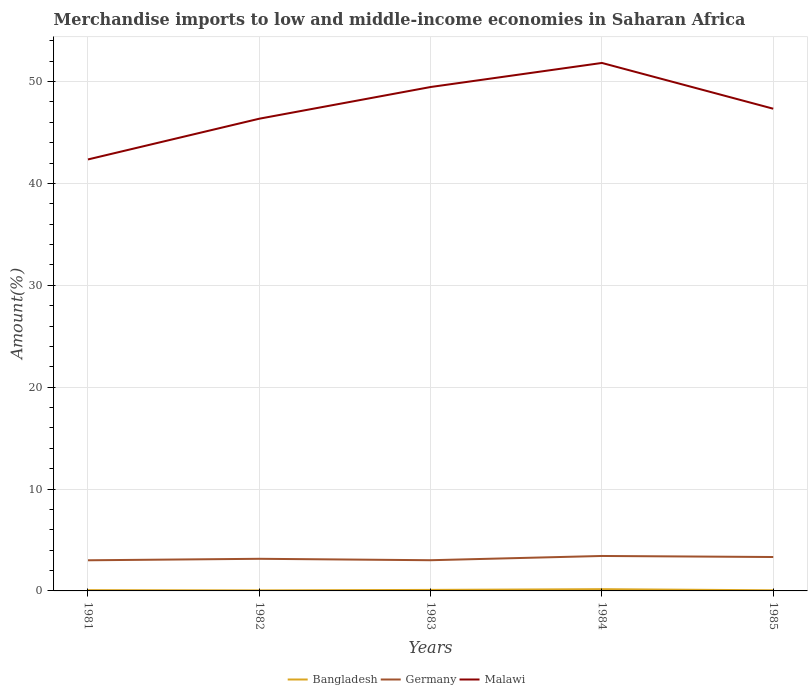Across all years, what is the maximum percentage of amount earned from merchandise imports in Malawi?
Your answer should be compact. 42.35. What is the total percentage of amount earned from merchandise imports in Germany in the graph?
Offer a very short reply. -0.15. What is the difference between the highest and the second highest percentage of amount earned from merchandise imports in Malawi?
Offer a very short reply. 9.47. How many lines are there?
Keep it short and to the point. 3. How many years are there in the graph?
Provide a succinct answer. 5. What is the difference between two consecutive major ticks on the Y-axis?
Offer a terse response. 10. What is the title of the graph?
Offer a terse response. Merchandise imports to low and middle-income economies in Saharan Africa. Does "Bolivia" appear as one of the legend labels in the graph?
Provide a short and direct response. No. What is the label or title of the Y-axis?
Make the answer very short. Amount(%). What is the Amount(%) of Bangladesh in 1981?
Your response must be concise. 0.07. What is the Amount(%) in Germany in 1981?
Keep it short and to the point. 3.01. What is the Amount(%) in Malawi in 1981?
Offer a terse response. 42.35. What is the Amount(%) of Bangladesh in 1982?
Provide a short and direct response. 0.05. What is the Amount(%) of Germany in 1982?
Give a very brief answer. 3.15. What is the Amount(%) of Malawi in 1982?
Your answer should be very brief. 46.35. What is the Amount(%) in Bangladesh in 1983?
Keep it short and to the point. 0.1. What is the Amount(%) in Germany in 1983?
Give a very brief answer. 3.01. What is the Amount(%) of Malawi in 1983?
Provide a succinct answer. 49.46. What is the Amount(%) in Bangladesh in 1984?
Your answer should be very brief. 0.17. What is the Amount(%) in Germany in 1984?
Offer a very short reply. 3.43. What is the Amount(%) in Malawi in 1984?
Offer a very short reply. 51.82. What is the Amount(%) of Bangladesh in 1985?
Your answer should be very brief. 0.06. What is the Amount(%) of Germany in 1985?
Offer a very short reply. 3.33. What is the Amount(%) in Malawi in 1985?
Provide a short and direct response. 47.33. Across all years, what is the maximum Amount(%) in Bangladesh?
Provide a short and direct response. 0.17. Across all years, what is the maximum Amount(%) of Germany?
Ensure brevity in your answer.  3.43. Across all years, what is the maximum Amount(%) in Malawi?
Your answer should be very brief. 51.82. Across all years, what is the minimum Amount(%) of Bangladesh?
Keep it short and to the point. 0.05. Across all years, what is the minimum Amount(%) of Germany?
Your answer should be very brief. 3.01. Across all years, what is the minimum Amount(%) in Malawi?
Make the answer very short. 42.35. What is the total Amount(%) of Bangladesh in the graph?
Your response must be concise. 0.46. What is the total Amount(%) in Germany in the graph?
Keep it short and to the point. 15.93. What is the total Amount(%) in Malawi in the graph?
Provide a short and direct response. 237.3. What is the difference between the Amount(%) of Bangladesh in 1981 and that in 1982?
Offer a very short reply. 0.02. What is the difference between the Amount(%) of Germany in 1981 and that in 1982?
Your response must be concise. -0.15. What is the difference between the Amount(%) in Malawi in 1981 and that in 1982?
Provide a succinct answer. -4. What is the difference between the Amount(%) of Bangladesh in 1981 and that in 1983?
Ensure brevity in your answer.  -0.02. What is the difference between the Amount(%) in Germany in 1981 and that in 1983?
Your answer should be compact. -0.01. What is the difference between the Amount(%) in Malawi in 1981 and that in 1983?
Make the answer very short. -7.11. What is the difference between the Amount(%) in Bangladesh in 1981 and that in 1984?
Give a very brief answer. -0.1. What is the difference between the Amount(%) of Germany in 1981 and that in 1984?
Your answer should be very brief. -0.42. What is the difference between the Amount(%) in Malawi in 1981 and that in 1984?
Give a very brief answer. -9.47. What is the difference between the Amount(%) of Bangladesh in 1981 and that in 1985?
Your answer should be very brief. 0.01. What is the difference between the Amount(%) of Germany in 1981 and that in 1985?
Give a very brief answer. -0.32. What is the difference between the Amount(%) in Malawi in 1981 and that in 1985?
Keep it short and to the point. -4.98. What is the difference between the Amount(%) in Bangladesh in 1982 and that in 1983?
Keep it short and to the point. -0.05. What is the difference between the Amount(%) in Germany in 1982 and that in 1983?
Offer a terse response. 0.14. What is the difference between the Amount(%) in Malawi in 1982 and that in 1983?
Offer a terse response. -3.11. What is the difference between the Amount(%) in Bangladesh in 1982 and that in 1984?
Offer a very short reply. -0.12. What is the difference between the Amount(%) in Germany in 1982 and that in 1984?
Offer a terse response. -0.28. What is the difference between the Amount(%) in Malawi in 1982 and that in 1984?
Give a very brief answer. -5.47. What is the difference between the Amount(%) of Bangladesh in 1982 and that in 1985?
Your response must be concise. -0.01. What is the difference between the Amount(%) in Germany in 1982 and that in 1985?
Your response must be concise. -0.17. What is the difference between the Amount(%) in Malawi in 1982 and that in 1985?
Offer a very short reply. -0.98. What is the difference between the Amount(%) in Bangladesh in 1983 and that in 1984?
Your answer should be compact. -0.07. What is the difference between the Amount(%) in Germany in 1983 and that in 1984?
Give a very brief answer. -0.42. What is the difference between the Amount(%) in Malawi in 1983 and that in 1984?
Make the answer very short. -2.36. What is the difference between the Amount(%) in Bangladesh in 1983 and that in 1985?
Your answer should be very brief. 0.04. What is the difference between the Amount(%) of Germany in 1983 and that in 1985?
Provide a short and direct response. -0.31. What is the difference between the Amount(%) of Malawi in 1983 and that in 1985?
Provide a short and direct response. 2.13. What is the difference between the Amount(%) in Bangladesh in 1984 and that in 1985?
Provide a short and direct response. 0.11. What is the difference between the Amount(%) in Germany in 1984 and that in 1985?
Your response must be concise. 0.1. What is the difference between the Amount(%) of Malawi in 1984 and that in 1985?
Your response must be concise. 4.49. What is the difference between the Amount(%) of Bangladesh in 1981 and the Amount(%) of Germany in 1982?
Ensure brevity in your answer.  -3.08. What is the difference between the Amount(%) in Bangladesh in 1981 and the Amount(%) in Malawi in 1982?
Give a very brief answer. -46.27. What is the difference between the Amount(%) in Germany in 1981 and the Amount(%) in Malawi in 1982?
Ensure brevity in your answer.  -43.34. What is the difference between the Amount(%) in Bangladesh in 1981 and the Amount(%) in Germany in 1983?
Offer a terse response. -2.94. What is the difference between the Amount(%) of Bangladesh in 1981 and the Amount(%) of Malawi in 1983?
Ensure brevity in your answer.  -49.38. What is the difference between the Amount(%) of Germany in 1981 and the Amount(%) of Malawi in 1983?
Provide a succinct answer. -46.45. What is the difference between the Amount(%) of Bangladesh in 1981 and the Amount(%) of Germany in 1984?
Offer a very short reply. -3.36. What is the difference between the Amount(%) of Bangladesh in 1981 and the Amount(%) of Malawi in 1984?
Offer a very short reply. -51.75. What is the difference between the Amount(%) in Germany in 1981 and the Amount(%) in Malawi in 1984?
Give a very brief answer. -48.81. What is the difference between the Amount(%) in Bangladesh in 1981 and the Amount(%) in Germany in 1985?
Make the answer very short. -3.25. What is the difference between the Amount(%) in Bangladesh in 1981 and the Amount(%) in Malawi in 1985?
Your answer should be very brief. -47.25. What is the difference between the Amount(%) in Germany in 1981 and the Amount(%) in Malawi in 1985?
Your answer should be compact. -44.32. What is the difference between the Amount(%) of Bangladesh in 1982 and the Amount(%) of Germany in 1983?
Ensure brevity in your answer.  -2.96. What is the difference between the Amount(%) in Bangladesh in 1982 and the Amount(%) in Malawi in 1983?
Provide a succinct answer. -49.41. What is the difference between the Amount(%) of Germany in 1982 and the Amount(%) of Malawi in 1983?
Provide a succinct answer. -46.3. What is the difference between the Amount(%) of Bangladesh in 1982 and the Amount(%) of Germany in 1984?
Offer a terse response. -3.38. What is the difference between the Amount(%) in Bangladesh in 1982 and the Amount(%) in Malawi in 1984?
Keep it short and to the point. -51.77. What is the difference between the Amount(%) in Germany in 1982 and the Amount(%) in Malawi in 1984?
Offer a terse response. -48.67. What is the difference between the Amount(%) of Bangladesh in 1982 and the Amount(%) of Germany in 1985?
Give a very brief answer. -3.28. What is the difference between the Amount(%) of Bangladesh in 1982 and the Amount(%) of Malawi in 1985?
Make the answer very short. -47.28. What is the difference between the Amount(%) of Germany in 1982 and the Amount(%) of Malawi in 1985?
Make the answer very short. -44.17. What is the difference between the Amount(%) in Bangladesh in 1983 and the Amount(%) in Germany in 1984?
Provide a succinct answer. -3.33. What is the difference between the Amount(%) of Bangladesh in 1983 and the Amount(%) of Malawi in 1984?
Your answer should be very brief. -51.72. What is the difference between the Amount(%) in Germany in 1983 and the Amount(%) in Malawi in 1984?
Your answer should be compact. -48.81. What is the difference between the Amount(%) of Bangladesh in 1983 and the Amount(%) of Germany in 1985?
Give a very brief answer. -3.23. What is the difference between the Amount(%) of Bangladesh in 1983 and the Amount(%) of Malawi in 1985?
Provide a succinct answer. -47.23. What is the difference between the Amount(%) in Germany in 1983 and the Amount(%) in Malawi in 1985?
Ensure brevity in your answer.  -44.31. What is the difference between the Amount(%) in Bangladesh in 1984 and the Amount(%) in Germany in 1985?
Provide a short and direct response. -3.16. What is the difference between the Amount(%) of Bangladesh in 1984 and the Amount(%) of Malawi in 1985?
Ensure brevity in your answer.  -47.16. What is the difference between the Amount(%) of Germany in 1984 and the Amount(%) of Malawi in 1985?
Provide a short and direct response. -43.9. What is the average Amount(%) of Bangladesh per year?
Your response must be concise. 0.09. What is the average Amount(%) of Germany per year?
Ensure brevity in your answer.  3.19. What is the average Amount(%) of Malawi per year?
Keep it short and to the point. 47.46. In the year 1981, what is the difference between the Amount(%) of Bangladesh and Amount(%) of Germany?
Offer a very short reply. -2.93. In the year 1981, what is the difference between the Amount(%) of Bangladesh and Amount(%) of Malawi?
Provide a succinct answer. -42.27. In the year 1981, what is the difference between the Amount(%) in Germany and Amount(%) in Malawi?
Give a very brief answer. -39.34. In the year 1982, what is the difference between the Amount(%) of Bangladesh and Amount(%) of Germany?
Your answer should be very brief. -3.1. In the year 1982, what is the difference between the Amount(%) in Bangladesh and Amount(%) in Malawi?
Ensure brevity in your answer.  -46.3. In the year 1982, what is the difference between the Amount(%) of Germany and Amount(%) of Malawi?
Give a very brief answer. -43.19. In the year 1983, what is the difference between the Amount(%) of Bangladesh and Amount(%) of Germany?
Make the answer very short. -2.91. In the year 1983, what is the difference between the Amount(%) in Bangladesh and Amount(%) in Malawi?
Ensure brevity in your answer.  -49.36. In the year 1983, what is the difference between the Amount(%) of Germany and Amount(%) of Malawi?
Make the answer very short. -46.44. In the year 1984, what is the difference between the Amount(%) of Bangladesh and Amount(%) of Germany?
Ensure brevity in your answer.  -3.26. In the year 1984, what is the difference between the Amount(%) in Bangladesh and Amount(%) in Malawi?
Ensure brevity in your answer.  -51.65. In the year 1984, what is the difference between the Amount(%) of Germany and Amount(%) of Malawi?
Your answer should be very brief. -48.39. In the year 1985, what is the difference between the Amount(%) of Bangladesh and Amount(%) of Germany?
Offer a very short reply. -3.27. In the year 1985, what is the difference between the Amount(%) of Bangladesh and Amount(%) of Malawi?
Your answer should be very brief. -47.27. In the year 1985, what is the difference between the Amount(%) of Germany and Amount(%) of Malawi?
Provide a short and direct response. -44. What is the ratio of the Amount(%) of Bangladesh in 1981 to that in 1982?
Offer a terse response. 1.44. What is the ratio of the Amount(%) in Germany in 1981 to that in 1982?
Provide a short and direct response. 0.95. What is the ratio of the Amount(%) in Malawi in 1981 to that in 1982?
Give a very brief answer. 0.91. What is the ratio of the Amount(%) in Bangladesh in 1981 to that in 1983?
Ensure brevity in your answer.  0.75. What is the ratio of the Amount(%) in Malawi in 1981 to that in 1983?
Offer a very short reply. 0.86. What is the ratio of the Amount(%) in Bangladesh in 1981 to that in 1984?
Your answer should be compact. 0.44. What is the ratio of the Amount(%) of Germany in 1981 to that in 1984?
Offer a very short reply. 0.88. What is the ratio of the Amount(%) of Malawi in 1981 to that in 1984?
Ensure brevity in your answer.  0.82. What is the ratio of the Amount(%) of Bangladesh in 1981 to that in 1985?
Provide a succinct answer. 1.23. What is the ratio of the Amount(%) in Germany in 1981 to that in 1985?
Provide a short and direct response. 0.9. What is the ratio of the Amount(%) in Malawi in 1981 to that in 1985?
Keep it short and to the point. 0.89. What is the ratio of the Amount(%) of Bangladesh in 1982 to that in 1983?
Your answer should be compact. 0.52. What is the ratio of the Amount(%) in Germany in 1982 to that in 1983?
Your response must be concise. 1.05. What is the ratio of the Amount(%) of Malawi in 1982 to that in 1983?
Keep it short and to the point. 0.94. What is the ratio of the Amount(%) of Bangladesh in 1982 to that in 1984?
Provide a succinct answer. 0.3. What is the ratio of the Amount(%) in Germany in 1982 to that in 1984?
Your answer should be compact. 0.92. What is the ratio of the Amount(%) of Malawi in 1982 to that in 1984?
Give a very brief answer. 0.89. What is the ratio of the Amount(%) in Bangladesh in 1982 to that in 1985?
Your answer should be very brief. 0.85. What is the ratio of the Amount(%) of Germany in 1982 to that in 1985?
Provide a short and direct response. 0.95. What is the ratio of the Amount(%) in Malawi in 1982 to that in 1985?
Give a very brief answer. 0.98. What is the ratio of the Amount(%) of Bangladesh in 1983 to that in 1984?
Your answer should be very brief. 0.58. What is the ratio of the Amount(%) of Germany in 1983 to that in 1984?
Give a very brief answer. 0.88. What is the ratio of the Amount(%) of Malawi in 1983 to that in 1984?
Keep it short and to the point. 0.95. What is the ratio of the Amount(%) of Bangladesh in 1983 to that in 1985?
Offer a very short reply. 1.64. What is the ratio of the Amount(%) in Germany in 1983 to that in 1985?
Offer a very short reply. 0.91. What is the ratio of the Amount(%) of Malawi in 1983 to that in 1985?
Your answer should be compact. 1.04. What is the ratio of the Amount(%) in Bangladesh in 1984 to that in 1985?
Your response must be concise. 2.83. What is the ratio of the Amount(%) in Germany in 1984 to that in 1985?
Provide a succinct answer. 1.03. What is the ratio of the Amount(%) in Malawi in 1984 to that in 1985?
Offer a very short reply. 1.09. What is the difference between the highest and the second highest Amount(%) of Bangladesh?
Give a very brief answer. 0.07. What is the difference between the highest and the second highest Amount(%) of Germany?
Keep it short and to the point. 0.1. What is the difference between the highest and the second highest Amount(%) in Malawi?
Your response must be concise. 2.36. What is the difference between the highest and the lowest Amount(%) of Bangladesh?
Provide a succinct answer. 0.12. What is the difference between the highest and the lowest Amount(%) in Germany?
Your answer should be compact. 0.42. What is the difference between the highest and the lowest Amount(%) of Malawi?
Ensure brevity in your answer.  9.47. 